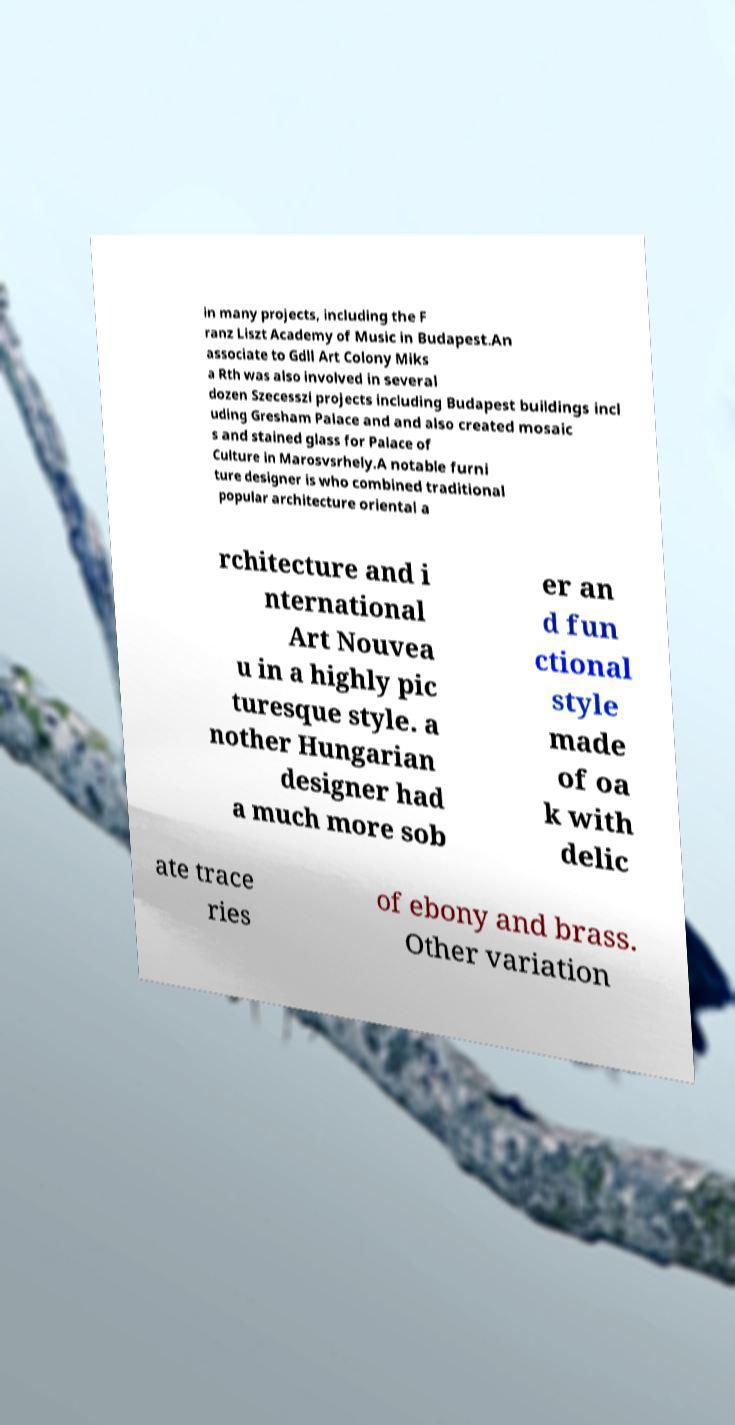Can you accurately transcribe the text from the provided image for me? in many projects, including the F ranz Liszt Academy of Music in Budapest.An associate to Gdll Art Colony Miks a Rth was also involved in several dozen Szecesszi projects including Budapest buildings incl uding Gresham Palace and and also created mosaic s and stained glass for Palace of Culture in Marosvsrhely.A notable furni ture designer is who combined traditional popular architecture oriental a rchitecture and i nternational Art Nouvea u in a highly pic turesque style. a nother Hungarian designer had a much more sob er an d fun ctional style made of oa k with delic ate trace ries of ebony and brass. Other variation 